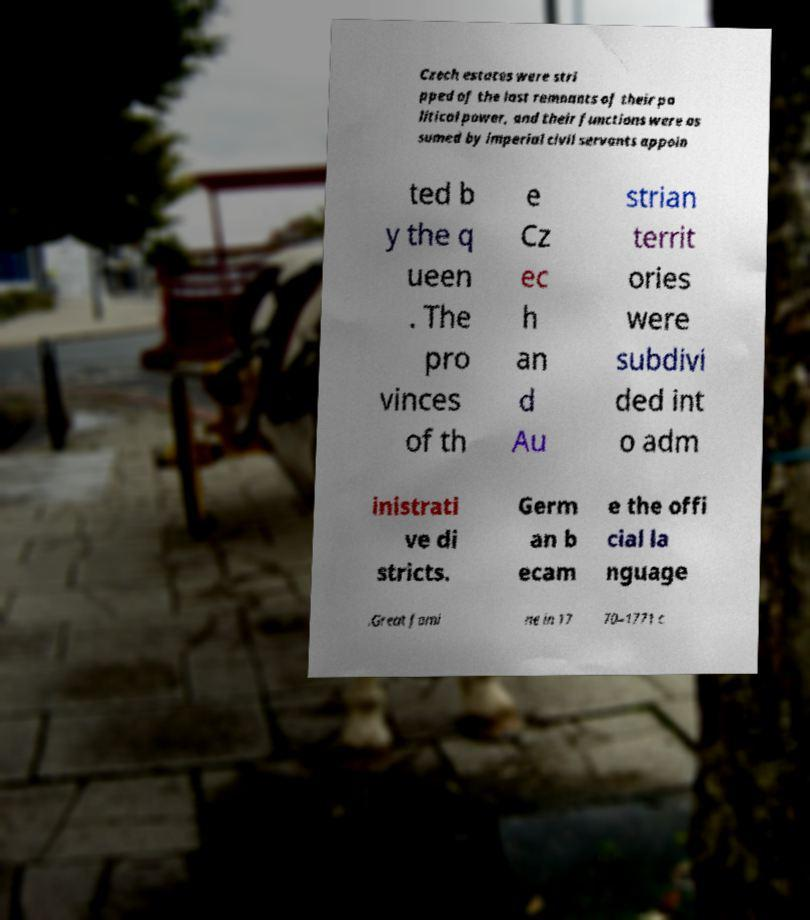Could you extract and type out the text from this image? Czech estates were stri pped of the last remnants of their po litical power, and their functions were as sumed by imperial civil servants appoin ted b y the q ueen . The pro vinces of th e Cz ec h an d Au strian territ ories were subdivi ded int o adm inistrati ve di stricts. Germ an b ecam e the offi cial la nguage .Great fami ne in 17 70–1771 c 